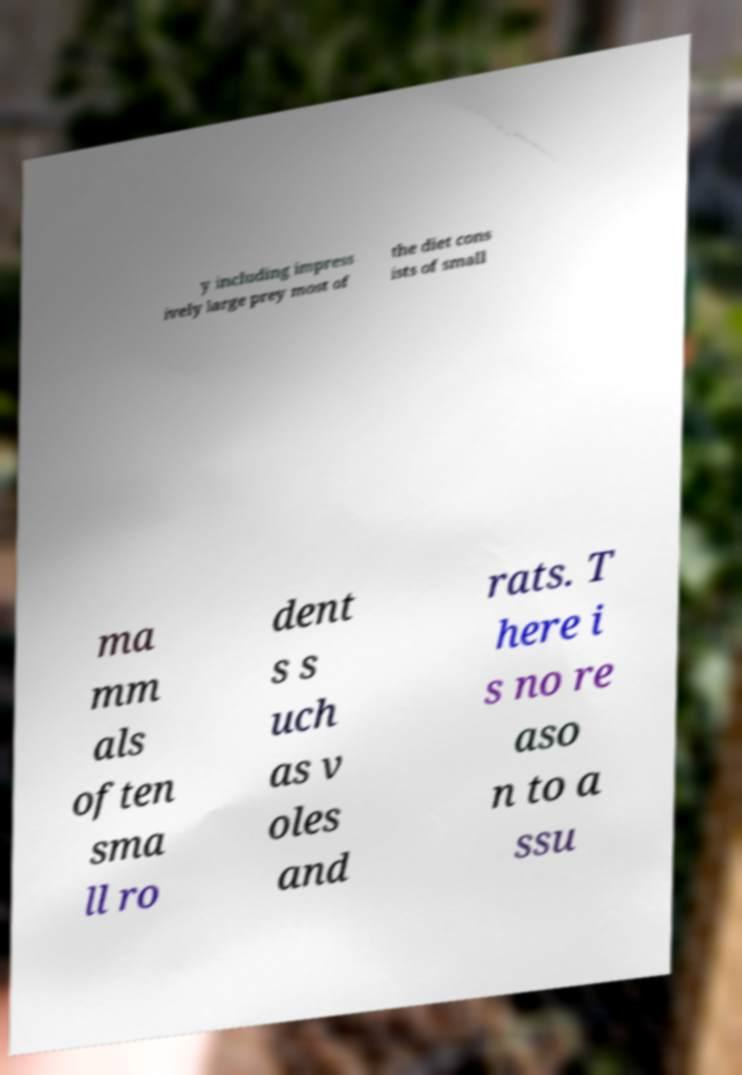Can you read and provide the text displayed in the image?This photo seems to have some interesting text. Can you extract and type it out for me? y including impress ively large prey most of the diet cons ists of small ma mm als often sma ll ro dent s s uch as v oles and rats. T here i s no re aso n to a ssu 